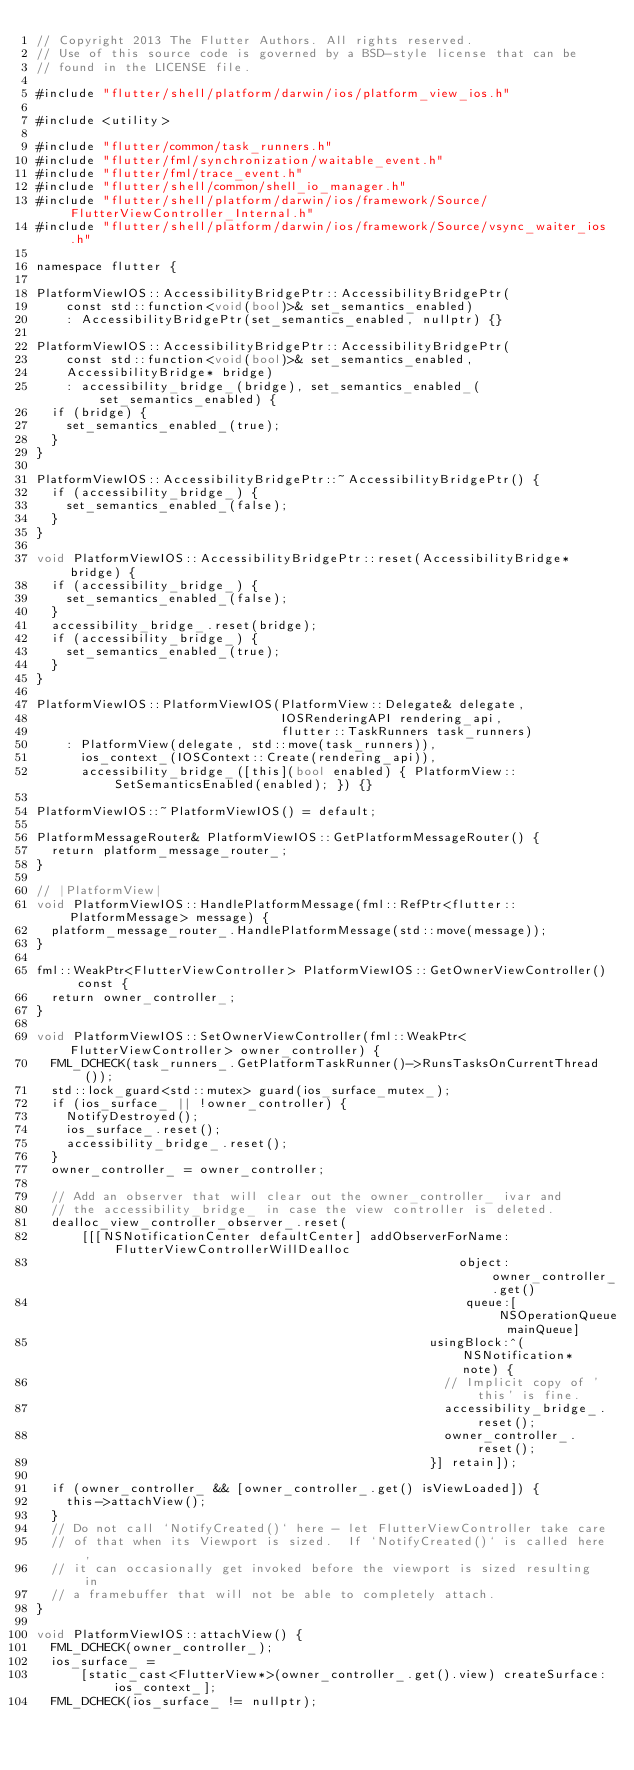<code> <loc_0><loc_0><loc_500><loc_500><_ObjectiveC_>// Copyright 2013 The Flutter Authors. All rights reserved.
// Use of this source code is governed by a BSD-style license that can be
// found in the LICENSE file.

#include "flutter/shell/platform/darwin/ios/platform_view_ios.h"

#include <utility>

#include "flutter/common/task_runners.h"
#include "flutter/fml/synchronization/waitable_event.h"
#include "flutter/fml/trace_event.h"
#include "flutter/shell/common/shell_io_manager.h"
#include "flutter/shell/platform/darwin/ios/framework/Source/FlutterViewController_Internal.h"
#include "flutter/shell/platform/darwin/ios/framework/Source/vsync_waiter_ios.h"

namespace flutter {

PlatformViewIOS::AccessibilityBridgePtr::AccessibilityBridgePtr(
    const std::function<void(bool)>& set_semantics_enabled)
    : AccessibilityBridgePtr(set_semantics_enabled, nullptr) {}

PlatformViewIOS::AccessibilityBridgePtr::AccessibilityBridgePtr(
    const std::function<void(bool)>& set_semantics_enabled,
    AccessibilityBridge* bridge)
    : accessibility_bridge_(bridge), set_semantics_enabled_(set_semantics_enabled) {
  if (bridge) {
    set_semantics_enabled_(true);
  }
}

PlatformViewIOS::AccessibilityBridgePtr::~AccessibilityBridgePtr() {
  if (accessibility_bridge_) {
    set_semantics_enabled_(false);
  }
}

void PlatformViewIOS::AccessibilityBridgePtr::reset(AccessibilityBridge* bridge) {
  if (accessibility_bridge_) {
    set_semantics_enabled_(false);
  }
  accessibility_bridge_.reset(bridge);
  if (accessibility_bridge_) {
    set_semantics_enabled_(true);
  }
}

PlatformViewIOS::PlatformViewIOS(PlatformView::Delegate& delegate,
                                 IOSRenderingAPI rendering_api,
                                 flutter::TaskRunners task_runners)
    : PlatformView(delegate, std::move(task_runners)),
      ios_context_(IOSContext::Create(rendering_api)),
      accessibility_bridge_([this](bool enabled) { PlatformView::SetSemanticsEnabled(enabled); }) {}

PlatformViewIOS::~PlatformViewIOS() = default;

PlatformMessageRouter& PlatformViewIOS::GetPlatformMessageRouter() {
  return platform_message_router_;
}

// |PlatformView|
void PlatformViewIOS::HandlePlatformMessage(fml::RefPtr<flutter::PlatformMessage> message) {
  platform_message_router_.HandlePlatformMessage(std::move(message));
}

fml::WeakPtr<FlutterViewController> PlatformViewIOS::GetOwnerViewController() const {
  return owner_controller_;
}

void PlatformViewIOS::SetOwnerViewController(fml::WeakPtr<FlutterViewController> owner_controller) {
  FML_DCHECK(task_runners_.GetPlatformTaskRunner()->RunsTasksOnCurrentThread());
  std::lock_guard<std::mutex> guard(ios_surface_mutex_);
  if (ios_surface_ || !owner_controller) {
    NotifyDestroyed();
    ios_surface_.reset();
    accessibility_bridge_.reset();
  }
  owner_controller_ = owner_controller;

  // Add an observer that will clear out the owner_controller_ ivar and
  // the accessibility_bridge_ in case the view controller is deleted.
  dealloc_view_controller_observer_.reset(
      [[[NSNotificationCenter defaultCenter] addObserverForName:FlutterViewControllerWillDealloc
                                                         object:owner_controller_.get()
                                                          queue:[NSOperationQueue mainQueue]
                                                     usingBlock:^(NSNotification* note) {
                                                       // Implicit copy of 'this' is fine.
                                                       accessibility_bridge_.reset();
                                                       owner_controller_.reset();
                                                     }] retain]);

  if (owner_controller_ && [owner_controller_.get() isViewLoaded]) {
    this->attachView();
  }
  // Do not call `NotifyCreated()` here - let FlutterViewController take care
  // of that when its Viewport is sized.  If `NotifyCreated()` is called here,
  // it can occasionally get invoked before the viewport is sized resulting in
  // a framebuffer that will not be able to completely attach.
}

void PlatformViewIOS::attachView() {
  FML_DCHECK(owner_controller_);
  ios_surface_ =
      [static_cast<FlutterView*>(owner_controller_.get().view) createSurface:ios_context_];
  FML_DCHECK(ios_surface_ != nullptr);
</code> 